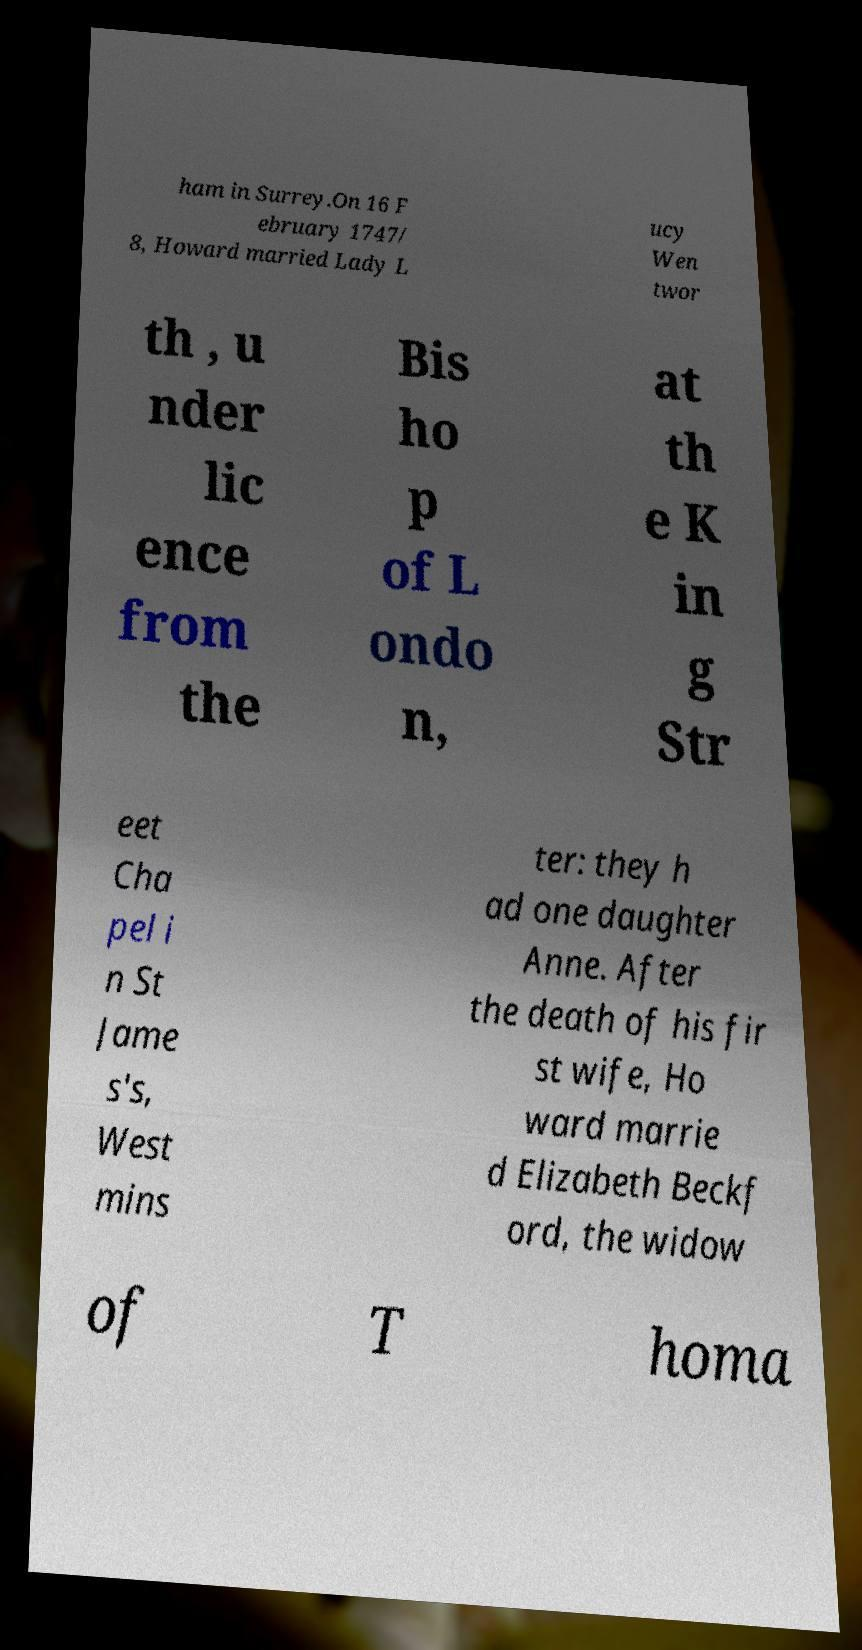Please identify and transcribe the text found in this image. ham in Surrey.On 16 F ebruary 1747/ 8, Howard married Lady L ucy Wen twor th , u nder lic ence from the Bis ho p of L ondo n, at th e K in g Str eet Cha pel i n St Jame s's, West mins ter: they h ad one daughter Anne. After the death of his fir st wife, Ho ward marrie d Elizabeth Beckf ord, the widow of T homa 